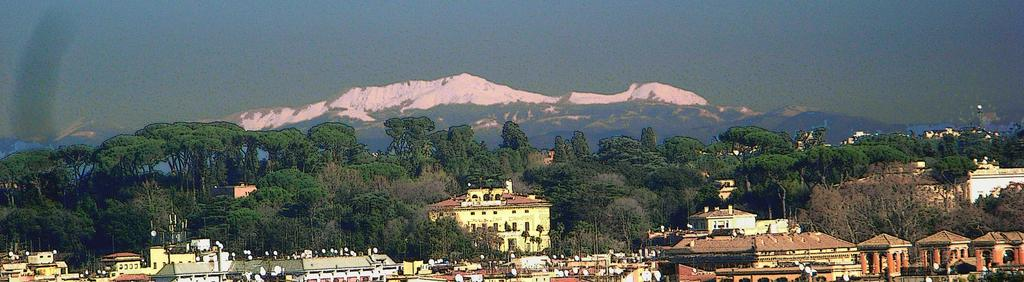What can be seen in the front of the image? There are buildings, trees, and objects in the front of the image. Are there any specific details about the objects in the front of the image? Unfortunately, the facts provided do not specify any details about the objects. What is visible in the background of the image? There are mountains and the sky in the background of the image. Can you describe the mountains in the background? Yes, there is snow on the mountain in the background. What flavor of train can be seen in the image? There is no train present in the image, so it is not possible to determine its flavor. 